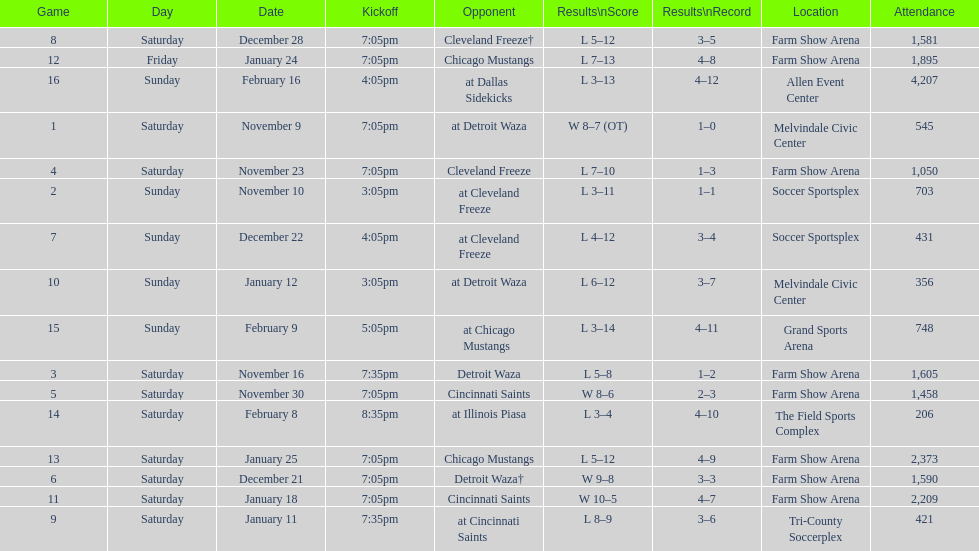How long was the teams longest losing streak? 5 games. 